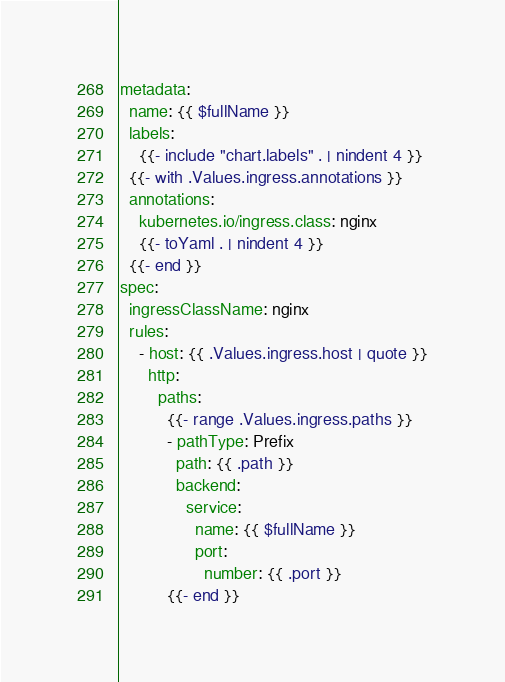Convert code to text. <code><loc_0><loc_0><loc_500><loc_500><_YAML_>metadata:
  name: {{ $fullName }}
  labels:
    {{- include "chart.labels" . | nindent 4 }}
  {{- with .Values.ingress.annotations }}
  annotations:
    kubernetes.io/ingress.class: nginx
    {{- toYaml . | nindent 4 }}
  {{- end }}
spec:
  ingressClassName: nginx
  rules:
    - host: {{ .Values.ingress.host | quote }}
      http:
        paths:
          {{- range .Values.ingress.paths }}
          - pathType: Prefix
            path: {{ .path }}
            backend:
              service:
                name: {{ $fullName }}
                port:
                  number: {{ .port }}
          {{- end }}
</code> 